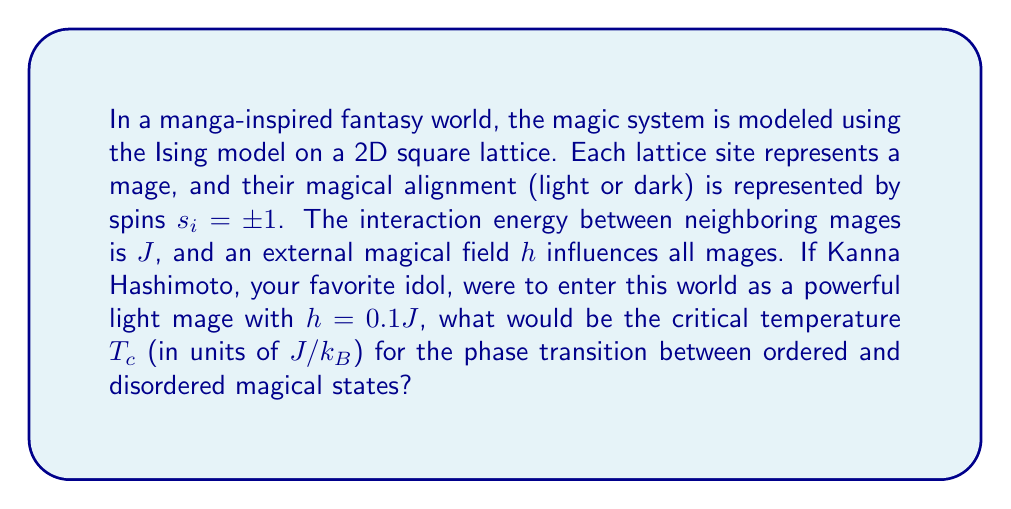Show me your answer to this math problem. To solve this problem, we'll use the Ising model in 2D and follow these steps:

1) The critical temperature for the 2D Ising model without an external field is given by Onsager's exact solution:

   $$T_c = \frac{2J}{k_B \ln(1+\sqrt{2})} \approx 2.269 \frac{J}{k_B}$$

2) However, we need to account for the external field $h$ introduced by Kanna Hashimoto. The presence of an external field typically shifts the critical temperature.

3) For small external fields, we can use a mean-field approximation to estimate the shift in critical temperature. The shift is proportional to $h^{2/3}$:

   $$T_c(h) \approx T_c(0) + A h^{2/3}$$

   where $A$ is a constant that depends on the system.

4) For the 2D Ising model, $A \approx 0.5$ in units of $(J/k_B)^{1/3}$.

5) Substituting the given value $h = 0.1J$:

   $$T_c(0.1J) \approx 2.269 \frac{J}{k_B} + 0.5 (0.1J)^{2/3}$$

6) Calculating:
   $$(0.1)^{2/3} \approx 0.2154$$
   $$0.5 \times 0.2154 \approx 0.1077$$

7) Therefore:

   $$T_c(0.1J) \approx 2.269 \frac{J}{k_B} + 0.1077 \frac{J}{k_B} \approx 2.3767 \frac{J}{k_B}$$
Answer: $2.3767 J/k_B$ 